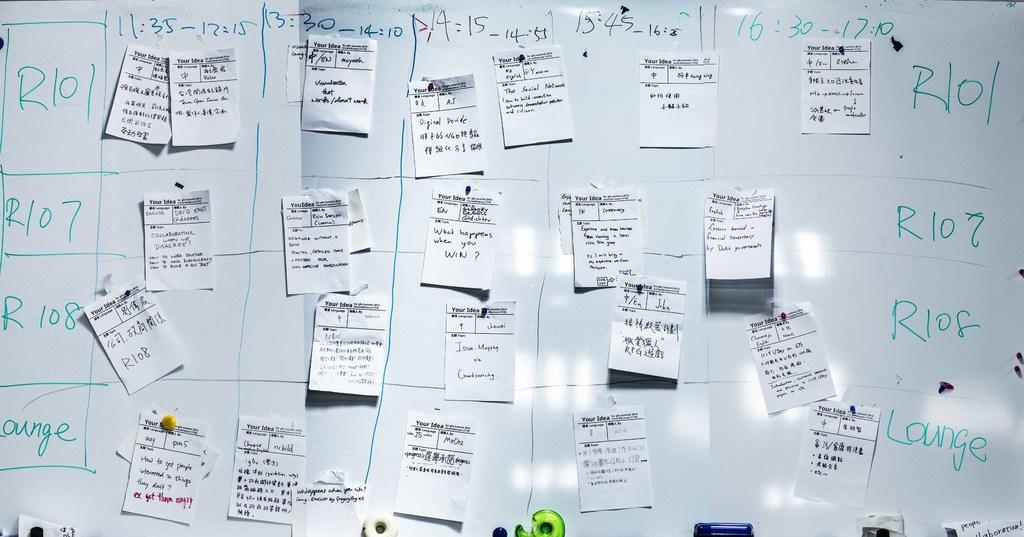<image>
Provide a brief description of the given image. A whiteboard has the word Lounge written on it and many notes taped to it. 